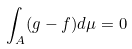<formula> <loc_0><loc_0><loc_500><loc_500>\int _ { A } ( g - f ) d \mu = 0</formula> 